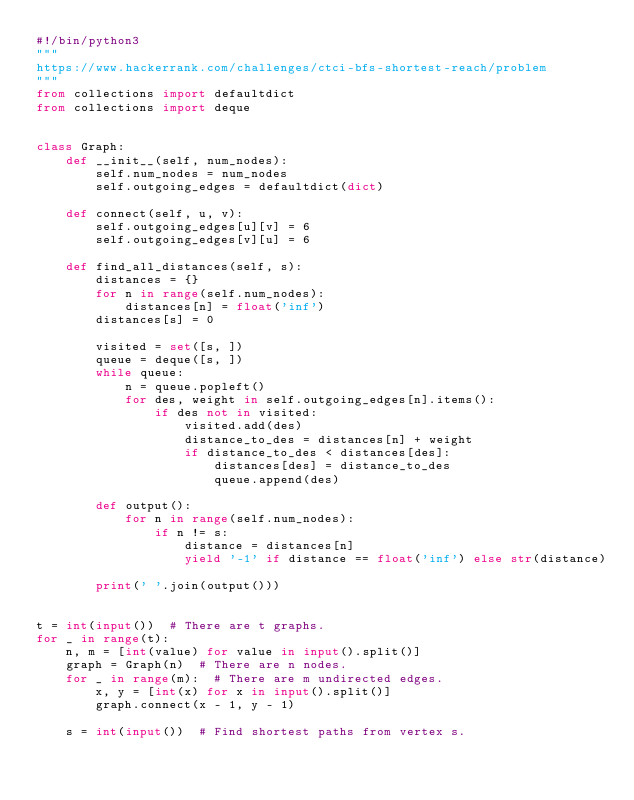<code> <loc_0><loc_0><loc_500><loc_500><_Python_>#!/bin/python3
"""
https://www.hackerrank.com/challenges/ctci-bfs-shortest-reach/problem
"""
from collections import defaultdict
from collections import deque


class Graph:
    def __init__(self, num_nodes):
        self.num_nodes = num_nodes
        self.outgoing_edges = defaultdict(dict)

    def connect(self, u, v):
        self.outgoing_edges[u][v] = 6
        self.outgoing_edges[v][u] = 6

    def find_all_distances(self, s):
        distances = {}
        for n in range(self.num_nodes):
            distances[n] = float('inf')
        distances[s] = 0

        visited = set([s, ])
        queue = deque([s, ])
        while queue:
            n = queue.popleft()
            for des, weight in self.outgoing_edges[n].items():
                if des not in visited:
                    visited.add(des)
                    distance_to_des = distances[n] + weight
                    if distance_to_des < distances[des]:
                        distances[des] = distance_to_des
                        queue.append(des)

        def output():
            for n in range(self.num_nodes):
                if n != s:
                    distance = distances[n]
                    yield '-1' if distance == float('inf') else str(distance)

        print(' '.join(output()))


t = int(input())  # There are t graphs.
for _ in range(t):
    n, m = [int(value) for value in input().split()]
    graph = Graph(n)  # There are n nodes.
    for _ in range(m):  # There are m undirected edges.
        x, y = [int(x) for x in input().split()]
        graph.connect(x - 1, y - 1)

    s = int(input())  # Find shortest paths from vertex s.</code> 